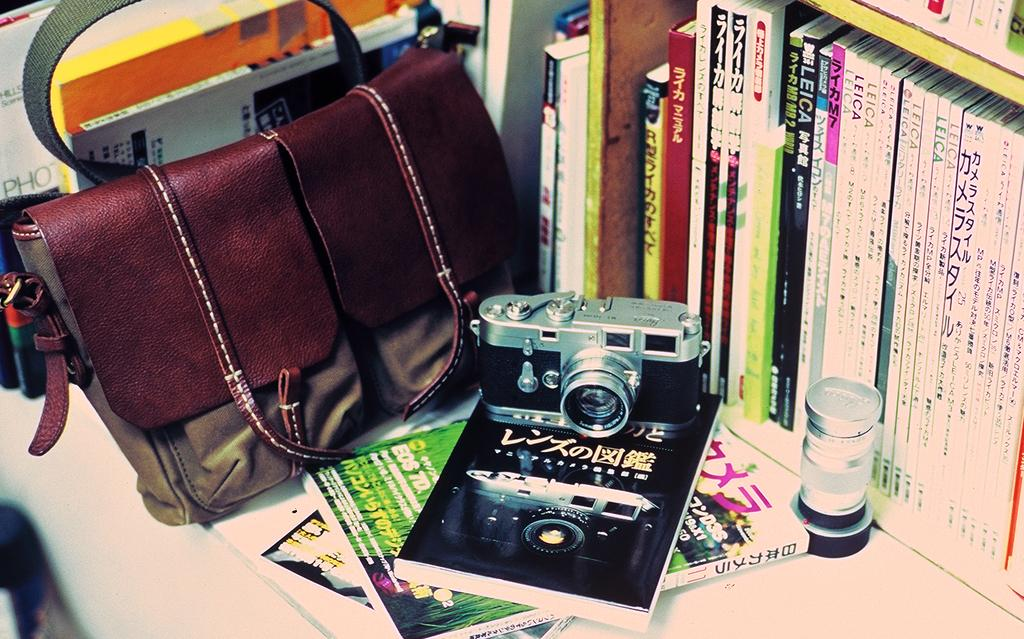What type of accessory is visible in the image? There is a handbag in the image. What device is present for capturing images? There is a camera in the image. Where are the books located in the image? The books are arranged on a shelf in the image. What type of frog can be seen participating in the feast in the image? There is no frog or feast present in the image. Is there an owl visible in the image? No, there is no owl present in the image. 